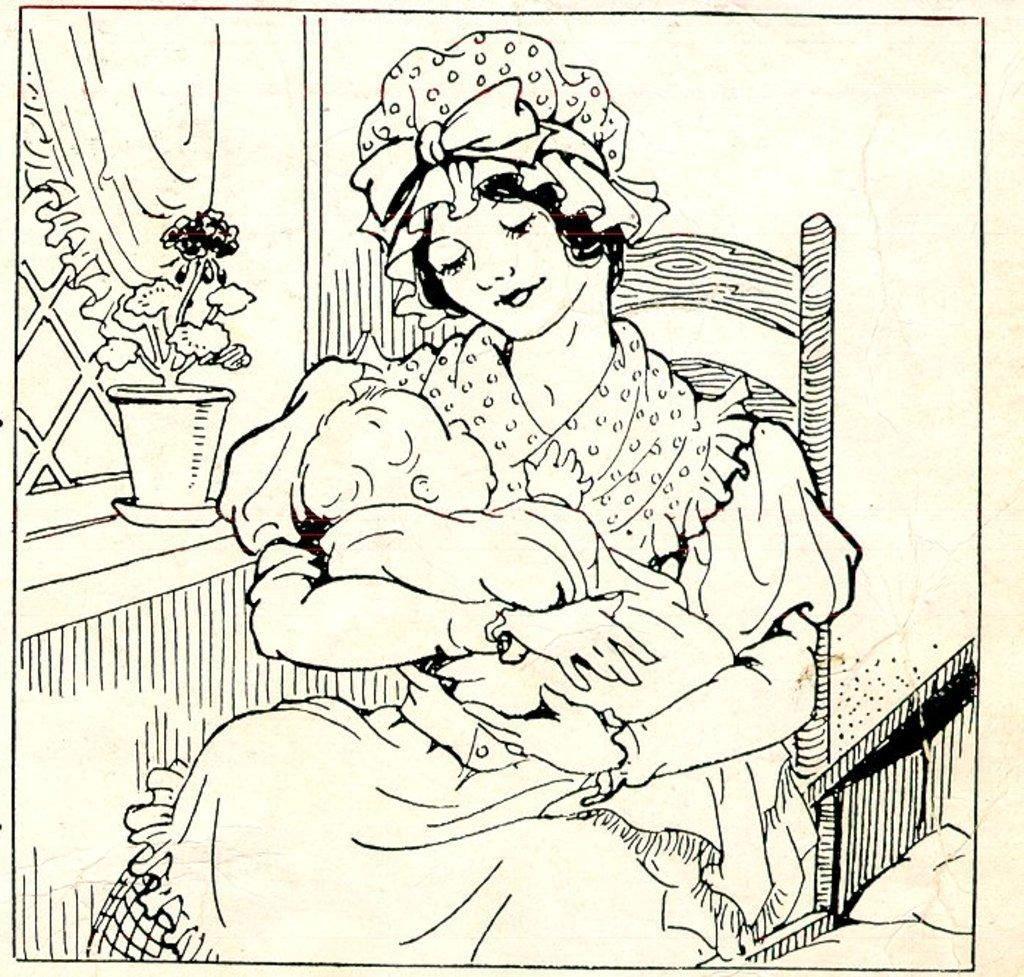What is depicted in the image? There is a printed sketch of a woman in the image. What is the woman doing in the image? The woman is holding a baby in the image. Where are the woman and baby sitting? The woman and baby are sitting on a chair in the image. What else can be seen in the image besides the woman and baby? There is a plant present in the image. What type of crown is the woman wearing in the image? There is no crown present in the image; the woman is not wearing any headgear. 